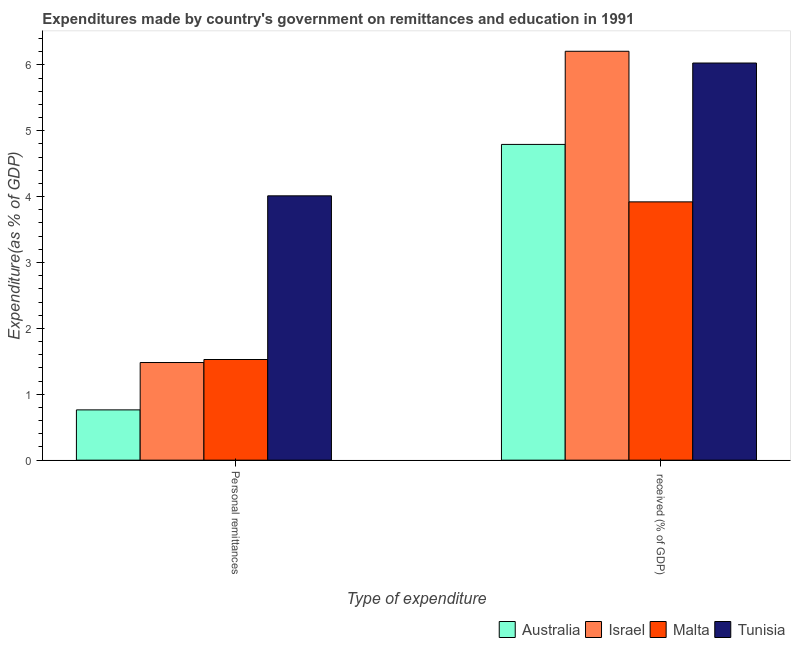Are the number of bars per tick equal to the number of legend labels?
Give a very brief answer. Yes. How many bars are there on the 2nd tick from the right?
Provide a succinct answer. 4. What is the label of the 1st group of bars from the left?
Your answer should be compact. Personal remittances. What is the expenditure in education in Tunisia?
Ensure brevity in your answer.  6.03. Across all countries, what is the maximum expenditure in education?
Give a very brief answer. 6.21. Across all countries, what is the minimum expenditure in education?
Keep it short and to the point. 3.92. In which country was the expenditure in education maximum?
Give a very brief answer. Israel. In which country was the expenditure in education minimum?
Make the answer very short. Malta. What is the total expenditure in personal remittances in the graph?
Make the answer very short. 7.78. What is the difference between the expenditure in personal remittances in Tunisia and that in Malta?
Offer a very short reply. 2.48. What is the difference between the expenditure in personal remittances in Israel and the expenditure in education in Australia?
Give a very brief answer. -3.31. What is the average expenditure in personal remittances per country?
Keep it short and to the point. 1.95. What is the difference between the expenditure in personal remittances and expenditure in education in Tunisia?
Your answer should be compact. -2.02. In how many countries, is the expenditure in personal remittances greater than 1.4 %?
Offer a terse response. 3. What is the ratio of the expenditure in personal remittances in Israel to that in Malta?
Your answer should be very brief. 0.97. In how many countries, is the expenditure in education greater than the average expenditure in education taken over all countries?
Ensure brevity in your answer.  2. What does the 2nd bar from the left in  received (% of GDP) represents?
Provide a succinct answer. Israel. How many bars are there?
Your answer should be very brief. 8. Are all the bars in the graph horizontal?
Your answer should be compact. No. Does the graph contain grids?
Your answer should be compact. No. Where does the legend appear in the graph?
Keep it short and to the point. Bottom right. How are the legend labels stacked?
Offer a very short reply. Horizontal. What is the title of the graph?
Ensure brevity in your answer.  Expenditures made by country's government on remittances and education in 1991. Does "Peru" appear as one of the legend labels in the graph?
Provide a short and direct response. No. What is the label or title of the X-axis?
Your answer should be compact. Type of expenditure. What is the label or title of the Y-axis?
Offer a terse response. Expenditure(as % of GDP). What is the Expenditure(as % of GDP) of Australia in Personal remittances?
Make the answer very short. 0.76. What is the Expenditure(as % of GDP) in Israel in Personal remittances?
Provide a short and direct response. 1.48. What is the Expenditure(as % of GDP) in Malta in Personal remittances?
Ensure brevity in your answer.  1.53. What is the Expenditure(as % of GDP) in Tunisia in Personal remittances?
Give a very brief answer. 4.01. What is the Expenditure(as % of GDP) of Australia in  received (% of GDP)?
Ensure brevity in your answer.  4.79. What is the Expenditure(as % of GDP) of Israel in  received (% of GDP)?
Make the answer very short. 6.21. What is the Expenditure(as % of GDP) in Malta in  received (% of GDP)?
Offer a very short reply. 3.92. What is the Expenditure(as % of GDP) in Tunisia in  received (% of GDP)?
Make the answer very short. 6.03. Across all Type of expenditure, what is the maximum Expenditure(as % of GDP) of Australia?
Offer a very short reply. 4.79. Across all Type of expenditure, what is the maximum Expenditure(as % of GDP) of Israel?
Provide a succinct answer. 6.21. Across all Type of expenditure, what is the maximum Expenditure(as % of GDP) of Malta?
Your response must be concise. 3.92. Across all Type of expenditure, what is the maximum Expenditure(as % of GDP) of Tunisia?
Provide a succinct answer. 6.03. Across all Type of expenditure, what is the minimum Expenditure(as % of GDP) of Australia?
Make the answer very short. 0.76. Across all Type of expenditure, what is the minimum Expenditure(as % of GDP) of Israel?
Make the answer very short. 1.48. Across all Type of expenditure, what is the minimum Expenditure(as % of GDP) of Malta?
Offer a very short reply. 1.53. Across all Type of expenditure, what is the minimum Expenditure(as % of GDP) of Tunisia?
Offer a very short reply. 4.01. What is the total Expenditure(as % of GDP) in Australia in the graph?
Make the answer very short. 5.56. What is the total Expenditure(as % of GDP) of Israel in the graph?
Keep it short and to the point. 7.69. What is the total Expenditure(as % of GDP) of Malta in the graph?
Your response must be concise. 5.45. What is the total Expenditure(as % of GDP) of Tunisia in the graph?
Your answer should be compact. 10.04. What is the difference between the Expenditure(as % of GDP) in Australia in Personal remittances and that in  received (% of GDP)?
Keep it short and to the point. -4.03. What is the difference between the Expenditure(as % of GDP) of Israel in Personal remittances and that in  received (% of GDP)?
Keep it short and to the point. -4.72. What is the difference between the Expenditure(as % of GDP) in Malta in Personal remittances and that in  received (% of GDP)?
Give a very brief answer. -2.39. What is the difference between the Expenditure(as % of GDP) in Tunisia in Personal remittances and that in  received (% of GDP)?
Offer a terse response. -2.02. What is the difference between the Expenditure(as % of GDP) of Australia in Personal remittances and the Expenditure(as % of GDP) of Israel in  received (% of GDP)?
Offer a very short reply. -5.44. What is the difference between the Expenditure(as % of GDP) in Australia in Personal remittances and the Expenditure(as % of GDP) in Malta in  received (% of GDP)?
Give a very brief answer. -3.16. What is the difference between the Expenditure(as % of GDP) of Australia in Personal remittances and the Expenditure(as % of GDP) of Tunisia in  received (% of GDP)?
Give a very brief answer. -5.26. What is the difference between the Expenditure(as % of GDP) of Israel in Personal remittances and the Expenditure(as % of GDP) of Malta in  received (% of GDP)?
Make the answer very short. -2.44. What is the difference between the Expenditure(as % of GDP) in Israel in Personal remittances and the Expenditure(as % of GDP) in Tunisia in  received (% of GDP)?
Your answer should be very brief. -4.55. What is the difference between the Expenditure(as % of GDP) in Malta in Personal remittances and the Expenditure(as % of GDP) in Tunisia in  received (% of GDP)?
Your response must be concise. -4.5. What is the average Expenditure(as % of GDP) of Australia per Type of expenditure?
Keep it short and to the point. 2.78. What is the average Expenditure(as % of GDP) of Israel per Type of expenditure?
Ensure brevity in your answer.  3.84. What is the average Expenditure(as % of GDP) in Malta per Type of expenditure?
Your answer should be very brief. 2.72. What is the average Expenditure(as % of GDP) in Tunisia per Type of expenditure?
Your answer should be very brief. 5.02. What is the difference between the Expenditure(as % of GDP) in Australia and Expenditure(as % of GDP) in Israel in Personal remittances?
Provide a short and direct response. -0.72. What is the difference between the Expenditure(as % of GDP) in Australia and Expenditure(as % of GDP) in Malta in Personal remittances?
Provide a succinct answer. -0.76. What is the difference between the Expenditure(as % of GDP) of Australia and Expenditure(as % of GDP) of Tunisia in Personal remittances?
Your answer should be very brief. -3.25. What is the difference between the Expenditure(as % of GDP) of Israel and Expenditure(as % of GDP) of Malta in Personal remittances?
Offer a very short reply. -0.05. What is the difference between the Expenditure(as % of GDP) in Israel and Expenditure(as % of GDP) in Tunisia in Personal remittances?
Your answer should be very brief. -2.53. What is the difference between the Expenditure(as % of GDP) of Malta and Expenditure(as % of GDP) of Tunisia in Personal remittances?
Provide a succinct answer. -2.48. What is the difference between the Expenditure(as % of GDP) in Australia and Expenditure(as % of GDP) in Israel in  received (% of GDP)?
Give a very brief answer. -1.41. What is the difference between the Expenditure(as % of GDP) in Australia and Expenditure(as % of GDP) in Malta in  received (% of GDP)?
Your answer should be very brief. 0.87. What is the difference between the Expenditure(as % of GDP) in Australia and Expenditure(as % of GDP) in Tunisia in  received (% of GDP)?
Offer a terse response. -1.24. What is the difference between the Expenditure(as % of GDP) in Israel and Expenditure(as % of GDP) in Malta in  received (% of GDP)?
Make the answer very short. 2.29. What is the difference between the Expenditure(as % of GDP) of Israel and Expenditure(as % of GDP) of Tunisia in  received (% of GDP)?
Ensure brevity in your answer.  0.18. What is the difference between the Expenditure(as % of GDP) of Malta and Expenditure(as % of GDP) of Tunisia in  received (% of GDP)?
Keep it short and to the point. -2.11. What is the ratio of the Expenditure(as % of GDP) of Australia in Personal remittances to that in  received (% of GDP)?
Make the answer very short. 0.16. What is the ratio of the Expenditure(as % of GDP) in Israel in Personal remittances to that in  received (% of GDP)?
Offer a terse response. 0.24. What is the ratio of the Expenditure(as % of GDP) in Malta in Personal remittances to that in  received (% of GDP)?
Offer a very short reply. 0.39. What is the ratio of the Expenditure(as % of GDP) of Tunisia in Personal remittances to that in  received (% of GDP)?
Your answer should be very brief. 0.67. What is the difference between the highest and the second highest Expenditure(as % of GDP) of Australia?
Offer a terse response. 4.03. What is the difference between the highest and the second highest Expenditure(as % of GDP) in Israel?
Provide a short and direct response. 4.72. What is the difference between the highest and the second highest Expenditure(as % of GDP) of Malta?
Offer a terse response. 2.39. What is the difference between the highest and the second highest Expenditure(as % of GDP) of Tunisia?
Offer a very short reply. 2.02. What is the difference between the highest and the lowest Expenditure(as % of GDP) of Australia?
Provide a short and direct response. 4.03. What is the difference between the highest and the lowest Expenditure(as % of GDP) of Israel?
Your answer should be very brief. 4.72. What is the difference between the highest and the lowest Expenditure(as % of GDP) of Malta?
Give a very brief answer. 2.39. What is the difference between the highest and the lowest Expenditure(as % of GDP) in Tunisia?
Your response must be concise. 2.02. 